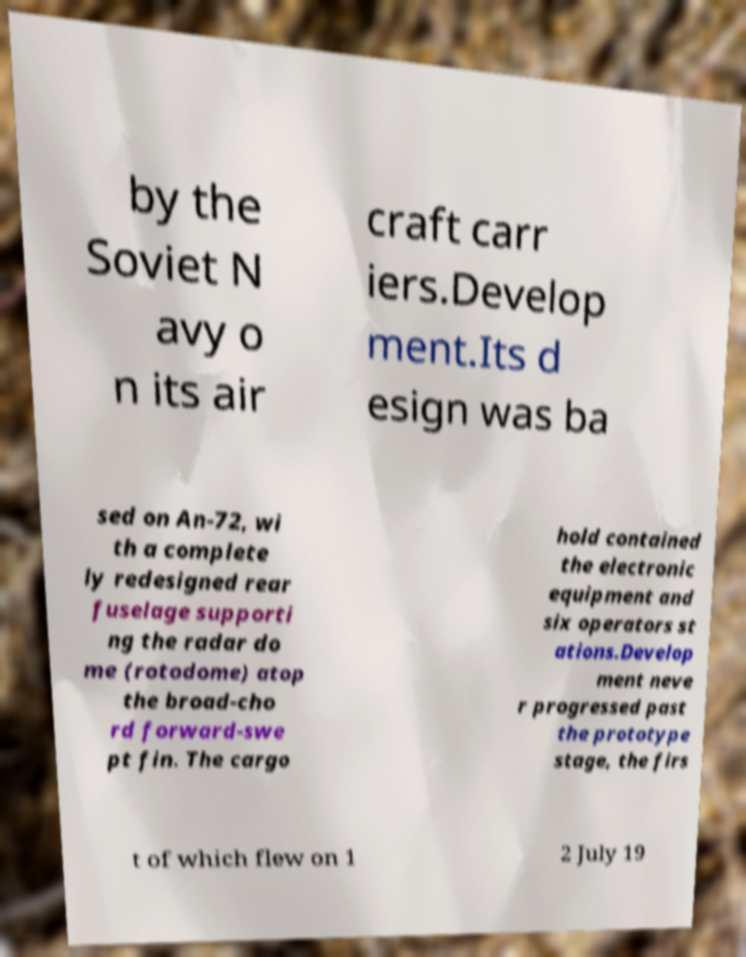I need the written content from this picture converted into text. Can you do that? by the Soviet N avy o n its air craft carr iers.Develop ment.Its d esign was ba sed on An-72, wi th a complete ly redesigned rear fuselage supporti ng the radar do me (rotodome) atop the broad-cho rd forward-swe pt fin. The cargo hold contained the electronic equipment and six operators st ations.Develop ment neve r progressed past the prototype stage, the firs t of which flew on 1 2 July 19 